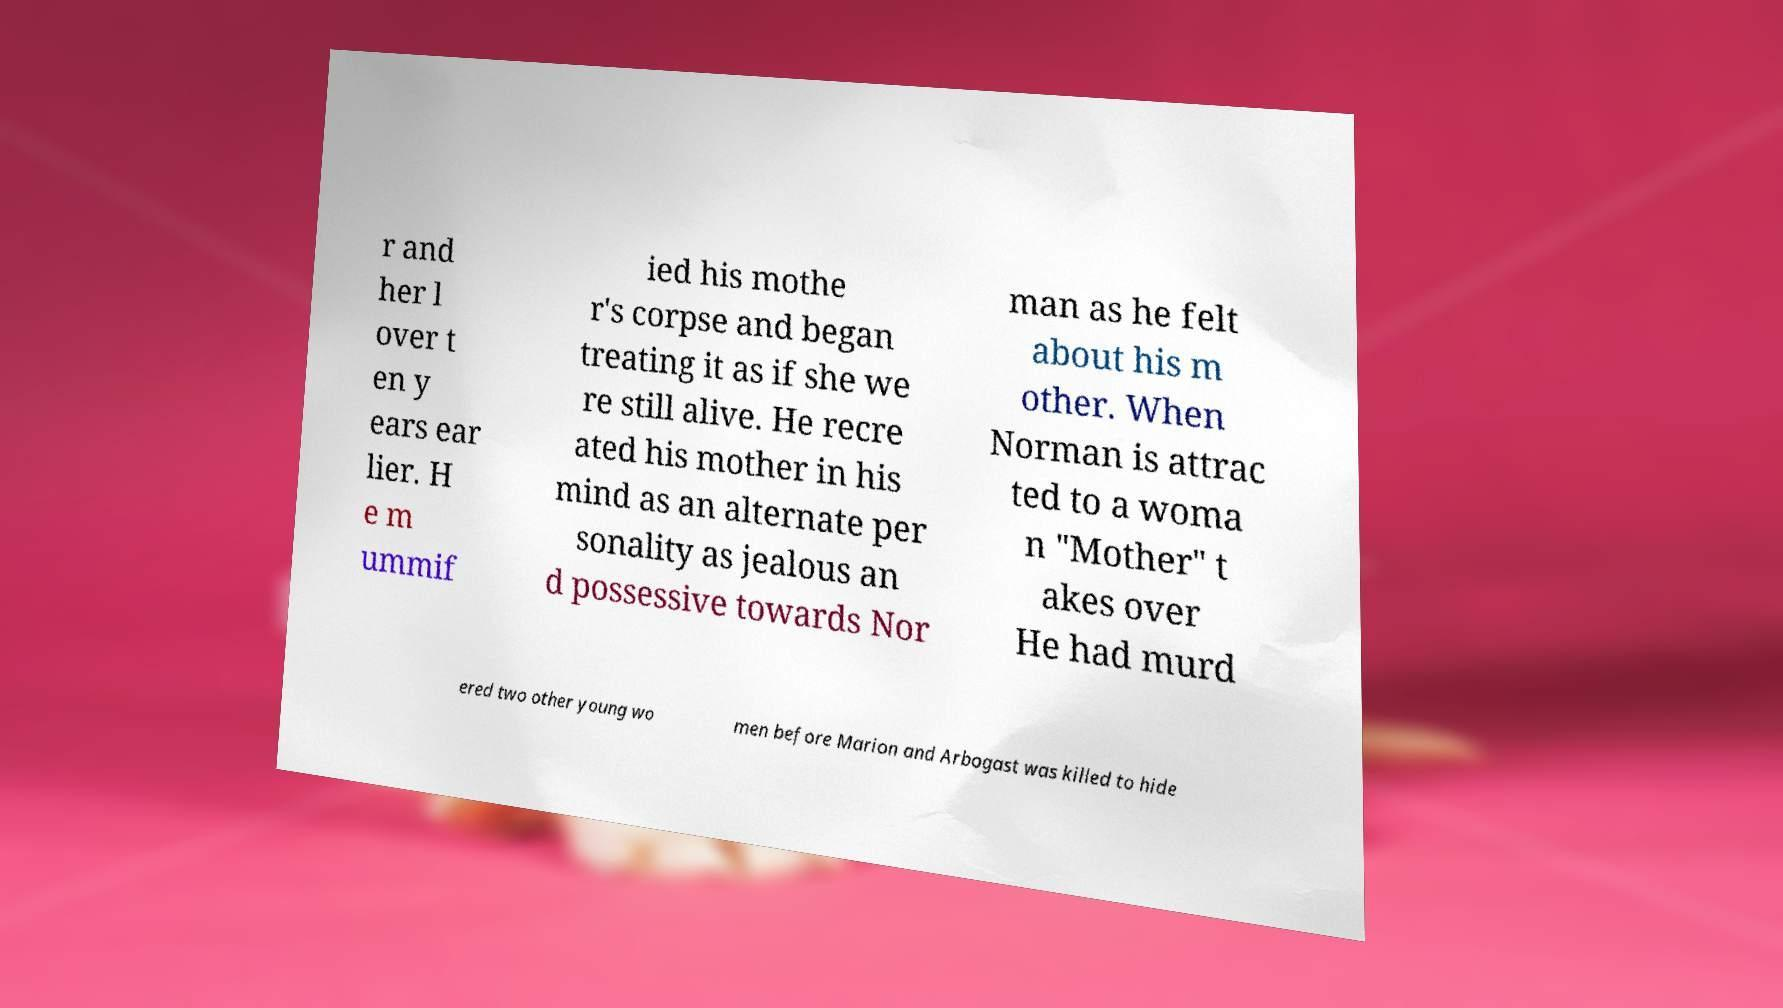I need the written content from this picture converted into text. Can you do that? r and her l over t en y ears ear lier. H e m ummif ied his mothe r's corpse and began treating it as if she we re still alive. He recre ated his mother in his mind as an alternate per sonality as jealous an d possessive towards Nor man as he felt about his m other. When Norman is attrac ted to a woma n "Mother" t akes over He had murd ered two other young wo men before Marion and Arbogast was killed to hide 